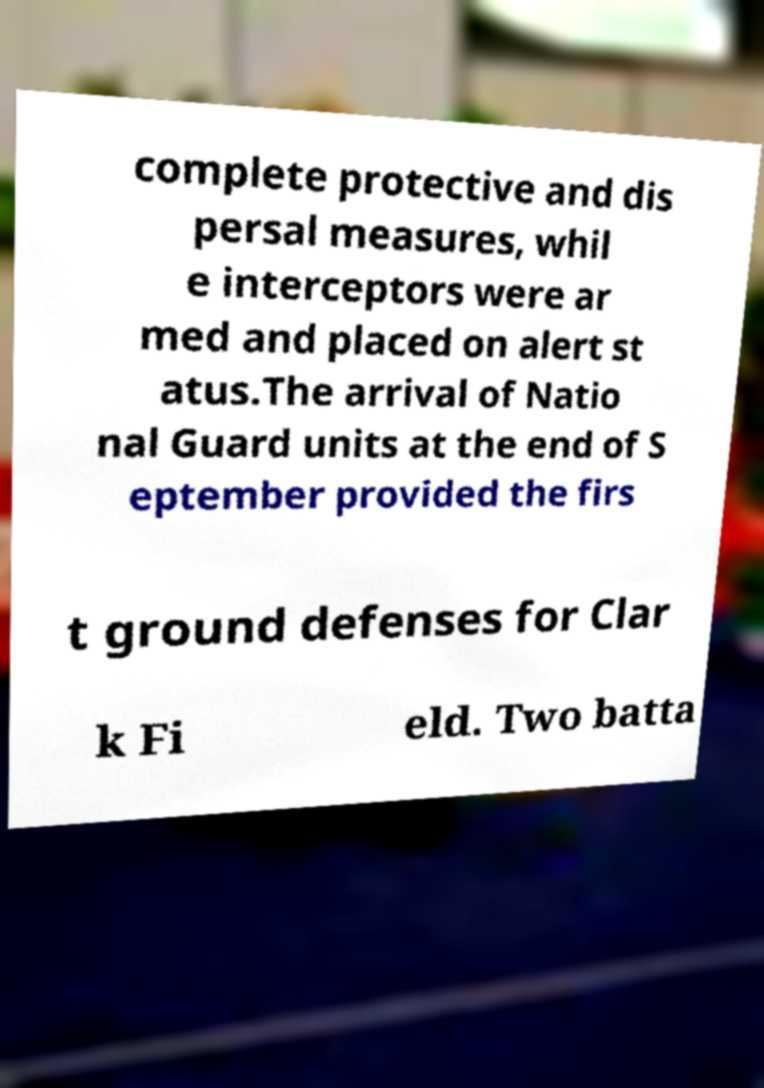Could you assist in decoding the text presented in this image and type it out clearly? complete protective and dis persal measures, whil e interceptors were ar med and placed on alert st atus.The arrival of Natio nal Guard units at the end of S eptember provided the firs t ground defenses for Clar k Fi eld. Two batta 